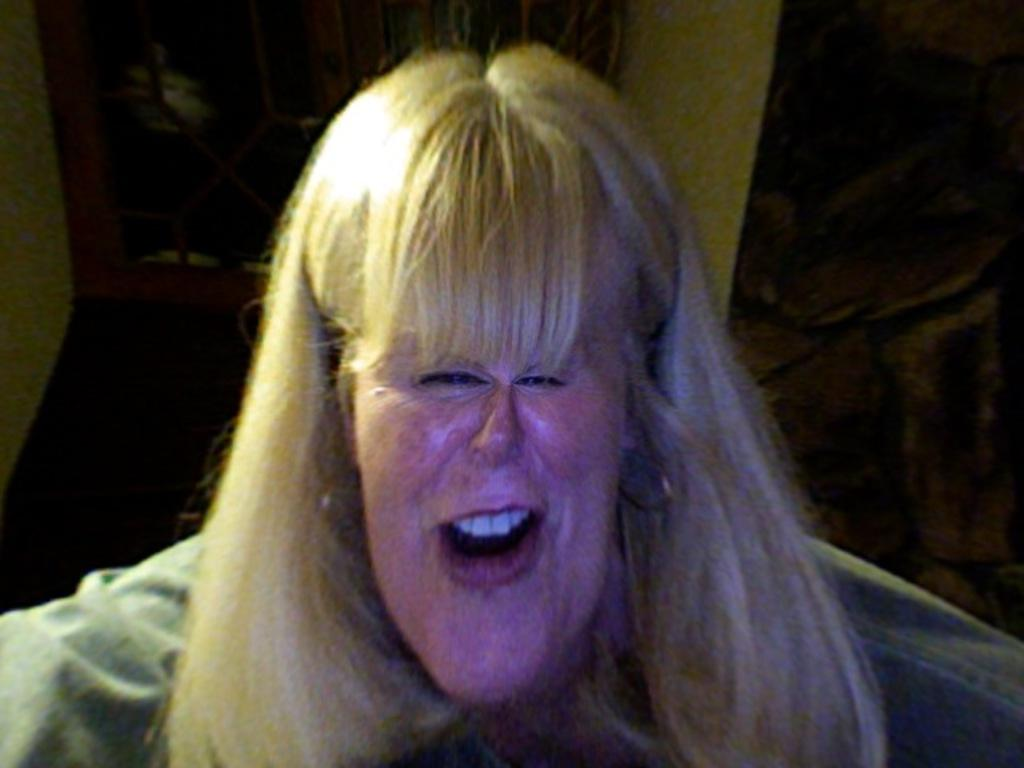What is the main subject of the image? There is a woman in the image. Can you describe the background of the image? There may be a wall in the background of the image. What type of drawer is visible in the image? There is no drawer present in the image. How many ploughs can be seen in the image? There are no ploughs present in the image. 